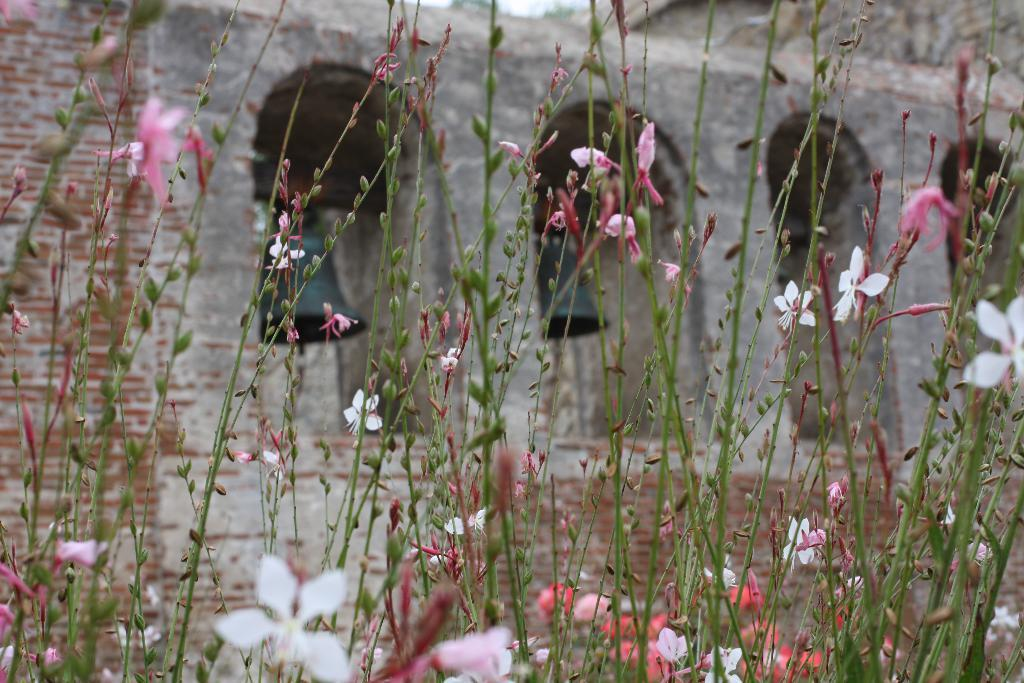What type of plants are visible in the image? There are plants with flowers in the image. What stage of growth are the plants in? The plants have buds on them. What can be seen in the background of the image? There is a building in the background of the image. What type of temper do the trains have in the image? There are no trains present in the image, so it is not possible to determine their temper. 